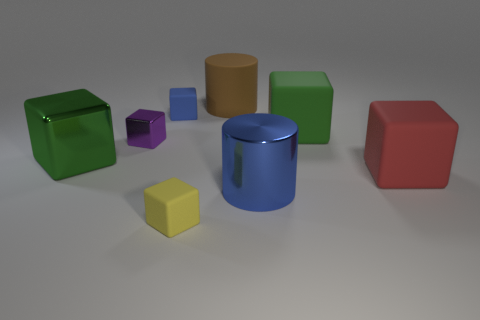Imagine these objects are part of a toy set. What could each color represent if they were part of a game? Let's indulge in a bit of imagination! The red cube might represent a fire element, green for earth, blue for water, and yellow for light or energy. The purple and brown shapes could be rare elements like magic or wood. Players could mix and match them to create or unlock new powers in the game. 